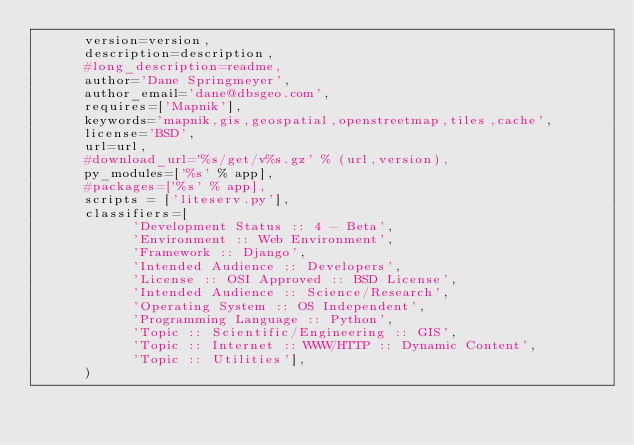Convert code to text. <code><loc_0><loc_0><loc_500><loc_500><_Python_>      version=version,
      description=description,
      #long_description=readme,
      author='Dane Springmeyer',
      author_email='dane@dbsgeo.com',
      requires=['Mapnik'],
      keywords='mapnik,gis,geospatial,openstreetmap,tiles,cache',
      license='BSD',
      url=url,
      #download_url='%s/get/v%s.gz' % (url,version),
      py_modules=['%s' % app],
      #packages=['%s' % app],
      scripts = ['liteserv.py'],
      classifiers=[
            'Development Status :: 4 - Beta',
            'Environment :: Web Environment',
            'Framework :: Django',
            'Intended Audience :: Developers',
            'License :: OSI Approved :: BSD License',
            'Intended Audience :: Science/Research',
            'Operating System :: OS Independent',
            'Programming Language :: Python',
            'Topic :: Scientific/Engineering :: GIS',
            'Topic :: Internet :: WWW/HTTP :: Dynamic Content',
            'Topic :: Utilities'],
      )
</code> 